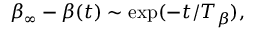Convert formula to latex. <formula><loc_0><loc_0><loc_500><loc_500>\beta _ { \infty } - \beta ( t ) \sim e x p ( - t / T _ { \beta } ) ,</formula> 